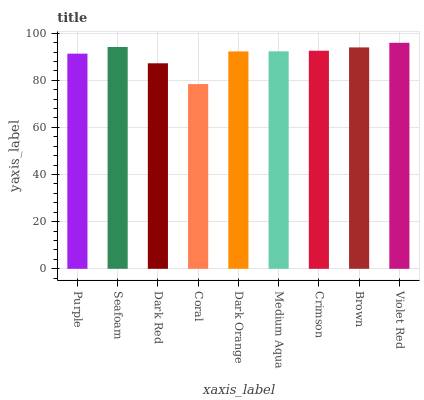Is Coral the minimum?
Answer yes or no. Yes. Is Violet Red the maximum?
Answer yes or no. Yes. Is Seafoam the minimum?
Answer yes or no. No. Is Seafoam the maximum?
Answer yes or no. No. Is Seafoam greater than Purple?
Answer yes or no. Yes. Is Purple less than Seafoam?
Answer yes or no. Yes. Is Purple greater than Seafoam?
Answer yes or no. No. Is Seafoam less than Purple?
Answer yes or no. No. Is Medium Aqua the high median?
Answer yes or no. Yes. Is Medium Aqua the low median?
Answer yes or no. Yes. Is Violet Red the high median?
Answer yes or no. No. Is Violet Red the low median?
Answer yes or no. No. 